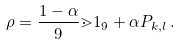Convert formula to latex. <formula><loc_0><loc_0><loc_500><loc_500>\rho = \frac { 1 - \alpha } { 9 } \mathbb { m } { 1 } _ { 9 } + \alpha P _ { k , l } \, .</formula> 